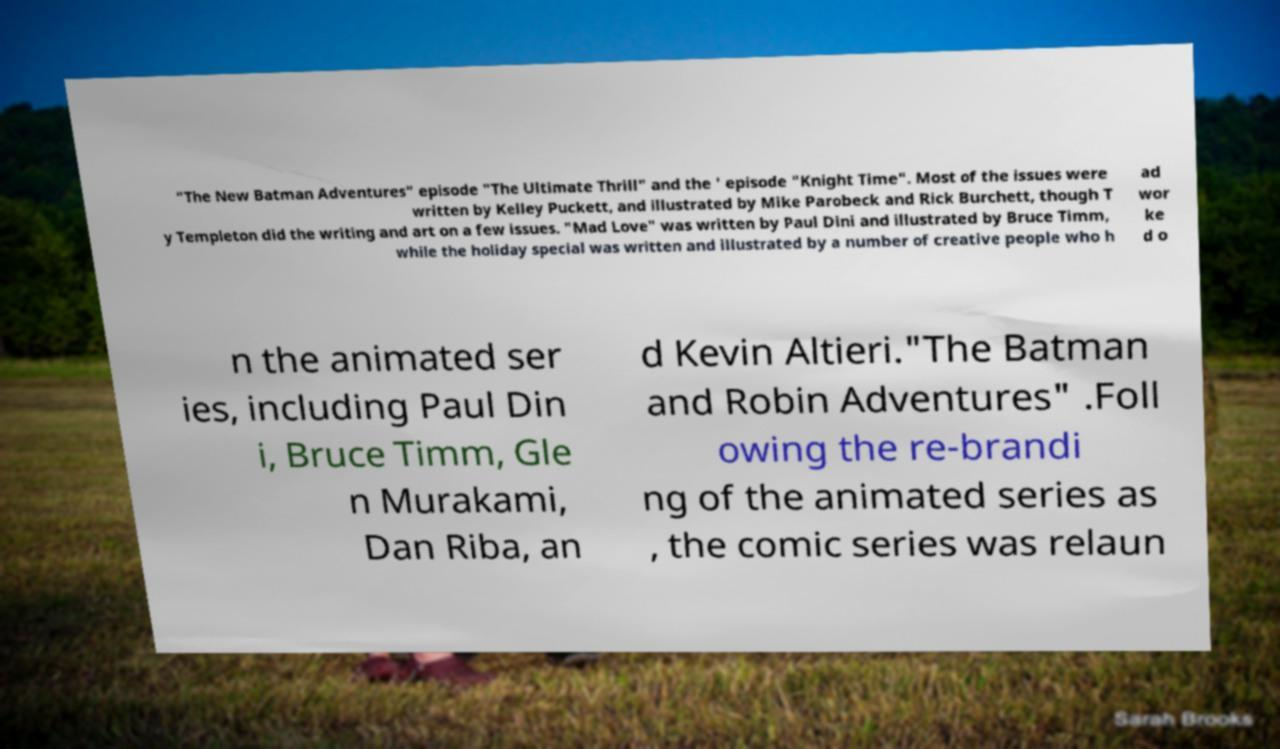Can you read and provide the text displayed in the image?This photo seems to have some interesting text. Can you extract and type it out for me? "The New Batman Adventures" episode "The Ultimate Thrill" and the ' episode "Knight Time". Most of the issues were written by Kelley Puckett, and illustrated by Mike Parobeck and Rick Burchett, though T y Templeton did the writing and art on a few issues. "Mad Love" was written by Paul Dini and illustrated by Bruce Timm, while the holiday special was written and illustrated by a number of creative people who h ad wor ke d o n the animated ser ies, including Paul Din i, Bruce Timm, Gle n Murakami, Dan Riba, an d Kevin Altieri."The Batman and Robin Adventures" .Foll owing the re-brandi ng of the animated series as , the comic series was relaun 